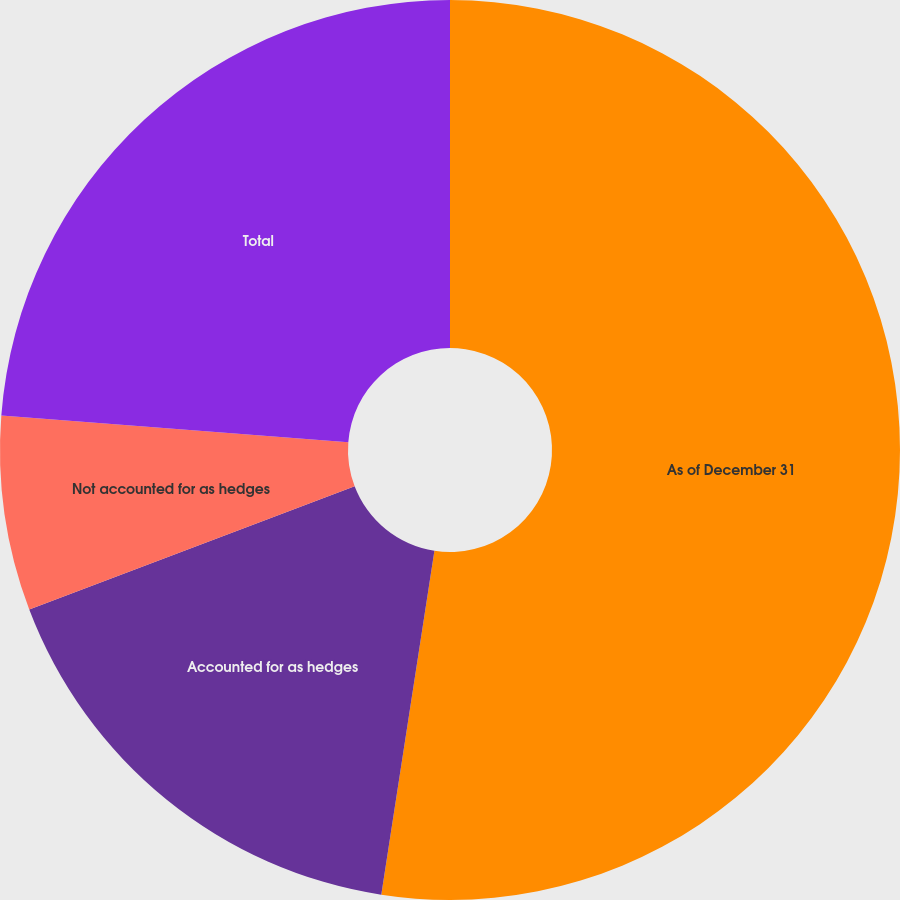Convert chart to OTSL. <chart><loc_0><loc_0><loc_500><loc_500><pie_chart><fcel>As of December 31<fcel>Accounted for as hedges<fcel>Not accounted for as hedges<fcel>Total<nl><fcel>52.44%<fcel>16.79%<fcel>6.99%<fcel>23.78%<nl></chart> 